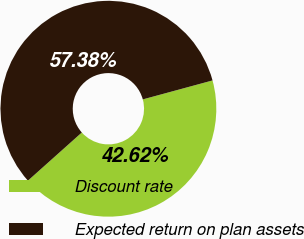Convert chart. <chart><loc_0><loc_0><loc_500><loc_500><pie_chart><fcel>Discount rate<fcel>Expected return on plan assets<nl><fcel>42.62%<fcel>57.38%<nl></chart> 